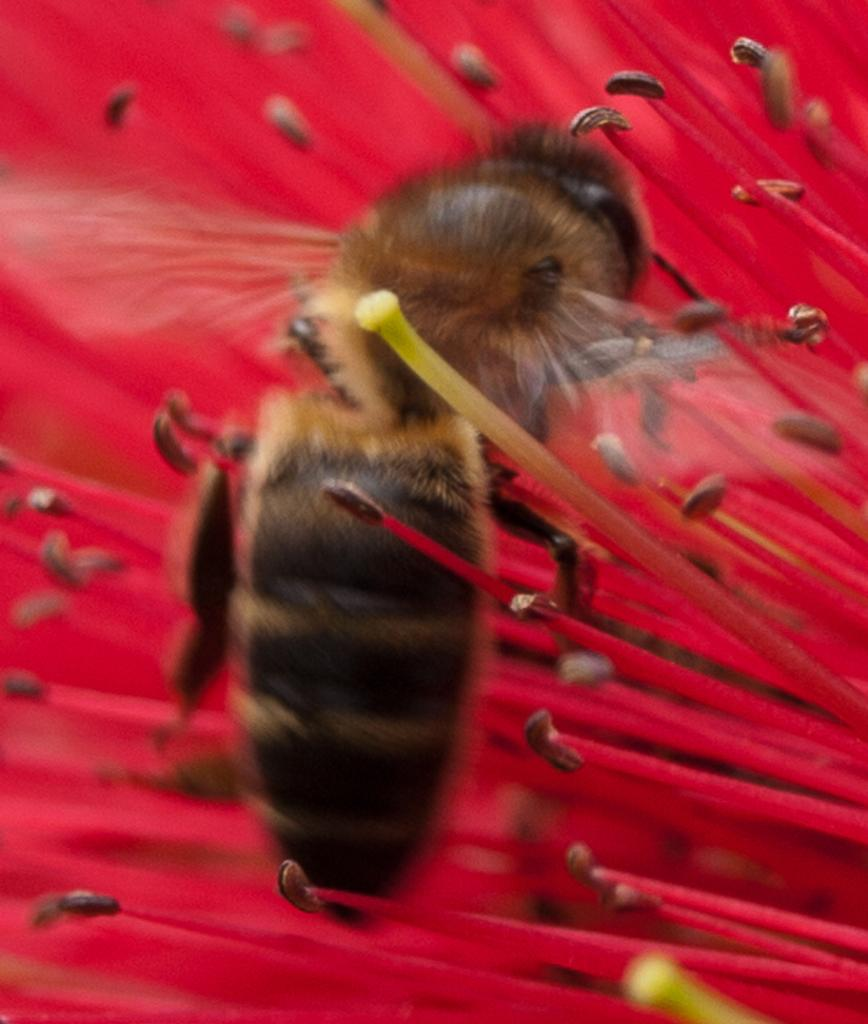What is the main subject of the picture? The main subject of the picture is a honey bee. Where is the honey bee located in the picture? The honey bee is standing on a red flower. What part of the brain can be seen in the picture? There is no part of the brain present in the picture; it features a honey bee on a red flower. 